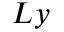<formula> <loc_0><loc_0><loc_500><loc_500>L y</formula> 